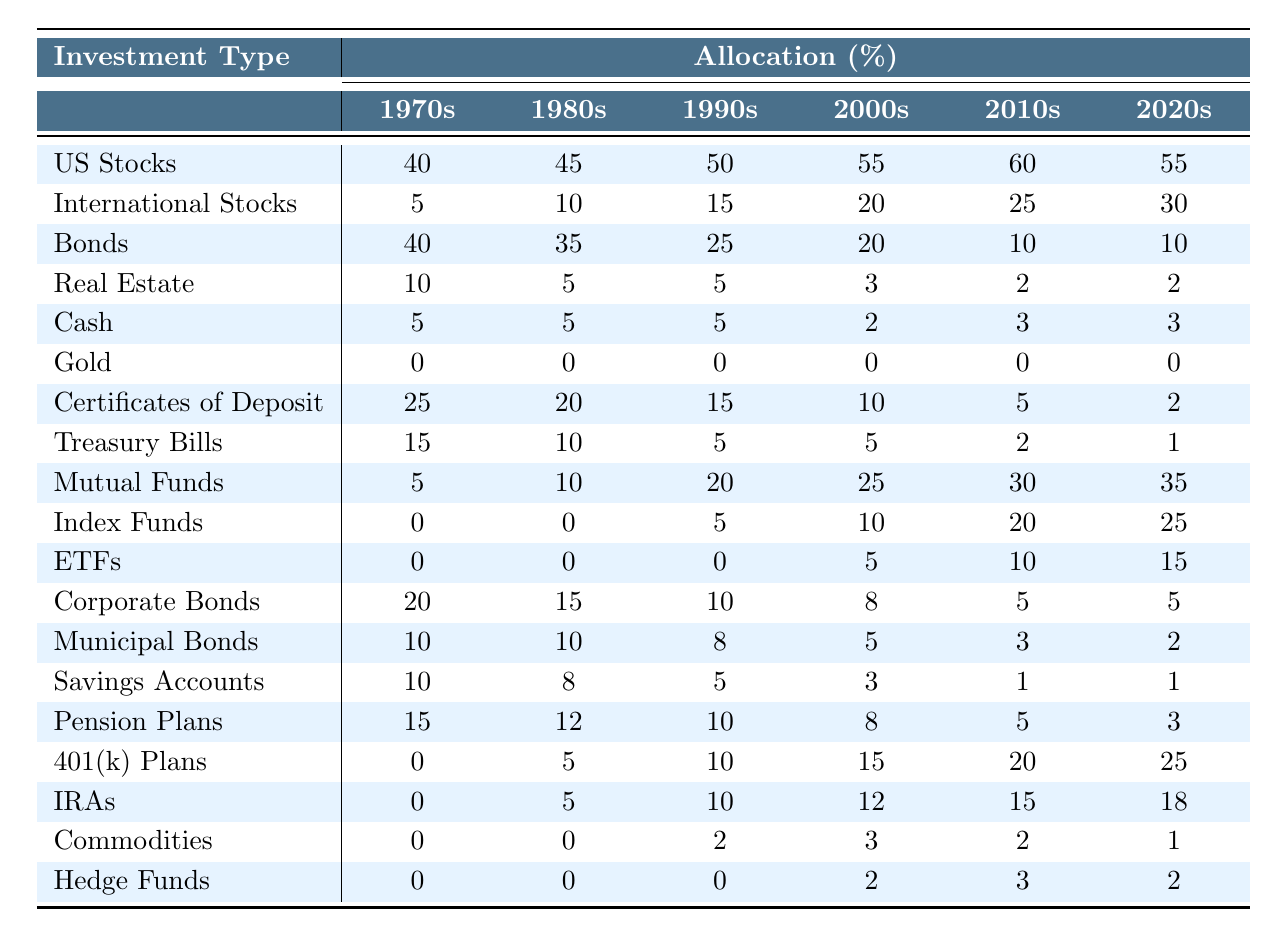What was the allocation for US Stocks in the 1980s? In the 1980s, the allocation for US Stocks is listed as 45%.
Answer: 45% How much did the allocation for International Stocks increase from the 1970s to the 2020s? The allocation for International Stocks was 5% in the 1970s and 30% in the 2020s. The increase is 30% - 5% = 25%.
Answer: 25% What percentage of the portfolio was allocated to Bonds in the 2000s? In the 2000s, the allocation for Bonds is recorded as 20%.
Answer: 20% Was there ever an allocation of Gold in any decade? The table shows an allocation of 0% for Gold in all decades, indicating it was never included.
Answer: No Which investment type had the highest allocation in the 2010s? In the 2010s, US Stocks had the highest allocation at 60%.
Answer: US Stocks What is the difference between the lowest and highest allocation of Cash over the decades? In the decades, Cash allocation was 5% in the 1970s and 1980s, and it dropped to 2% in the 2000s. The highest allocation for Cash was 5% and the lowest was 2%, so the difference is 5% - 2% = 3%.
Answer: 3% How much did the allocation for 401(k) Plans increase from the 2000s to the 2020s? The allocation for 401(k) Plans increased from 15% in the 2000s to 25% in the 2020s. The increase is calculated as 25% - 15% = 10%.
Answer: 10% What was the average allocation for Mutual Funds over the decades? The total allocation for Mutual Funds over the decades is (5 + 10 + 20 + 25 + 30 + 35) = 125%. There are 6 data points, so the average is 125% / 6 = approximately 20.83%.
Answer: 20.83% In which decade did Savings Accounts have the lowest allocation? The table shows that Savings Accounts had the lowest allocation of 1% in the 2010s and 2020s.
Answer: 2010s and 2020s How many types of investments had an allocation of 0% in the 1990s? In the 1990s, both Gold and Index Funds had allocations of 0%. This means there are 2 types of investments with 0% allocation.
Answer: 2 What trend can be observed in the allocation for Real Estate over the decades? The allocation for Real Estate decreased from 10% in the 1970s to 2% in the 2020s, indicating a downward trend.
Answer: Downward trend 